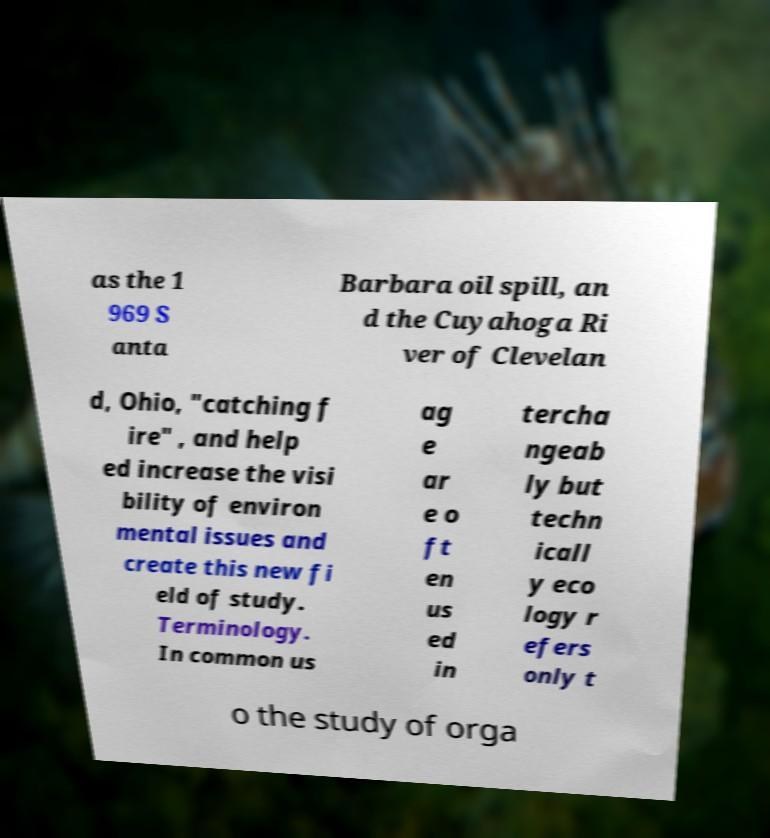What messages or text are displayed in this image? I need them in a readable, typed format. as the 1 969 S anta Barbara oil spill, an d the Cuyahoga Ri ver of Clevelan d, Ohio, "catching f ire" , and help ed increase the visi bility of environ mental issues and create this new fi eld of study. Terminology. In common us ag e ar e o ft en us ed in tercha ngeab ly but techn icall y eco logy r efers only t o the study of orga 